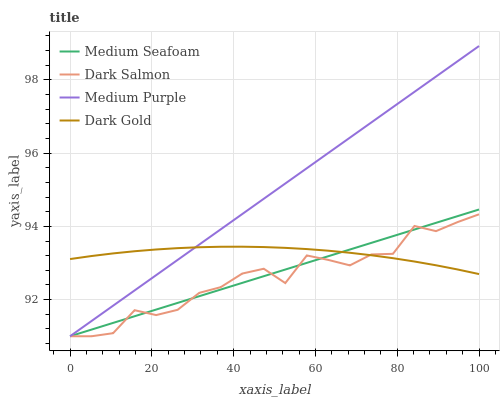Does Dark Gold have the minimum area under the curve?
Answer yes or no. No. Does Dark Gold have the maximum area under the curve?
Answer yes or no. No. Is Dark Gold the smoothest?
Answer yes or no. No. Is Dark Gold the roughest?
Answer yes or no. No. Does Dark Gold have the lowest value?
Answer yes or no. No. Does Medium Seafoam have the highest value?
Answer yes or no. No. 